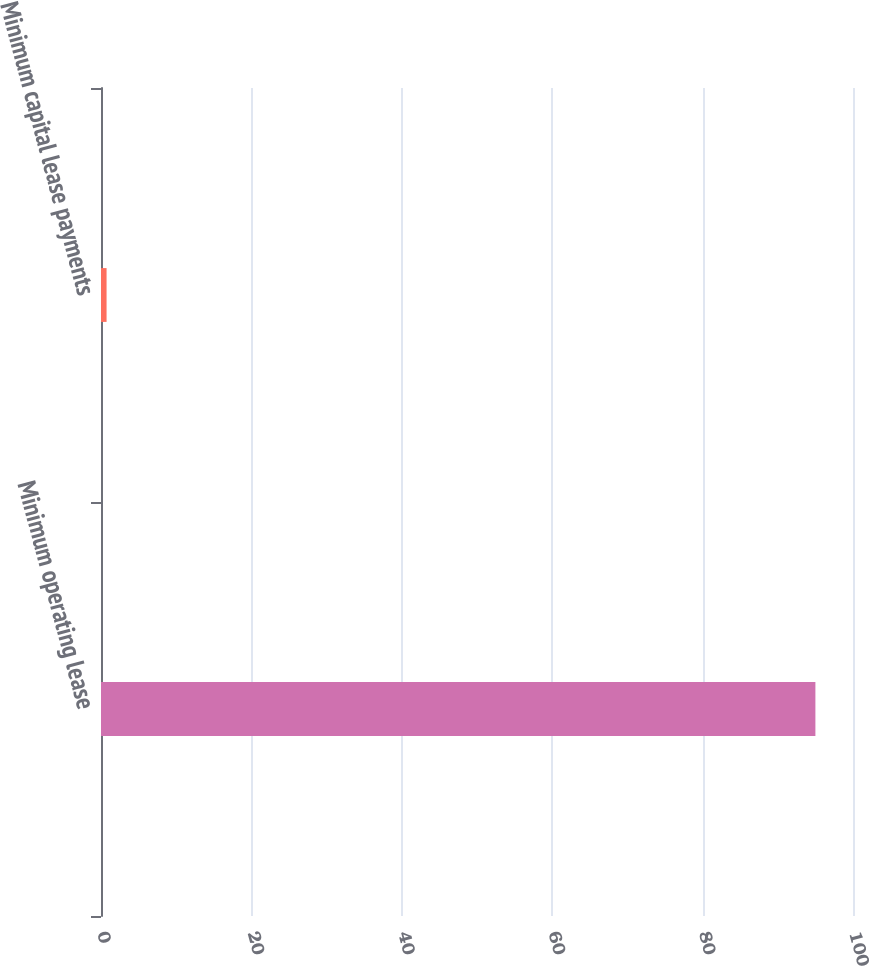Convert chart to OTSL. <chart><loc_0><loc_0><loc_500><loc_500><bar_chart><fcel>Minimum operating lease<fcel>Minimum capital lease payments<nl><fcel>95<fcel>0.74<nl></chart> 